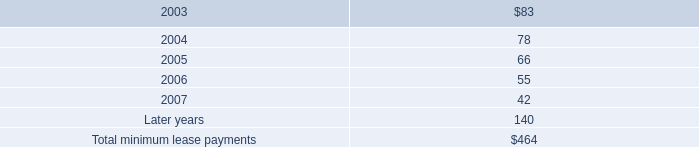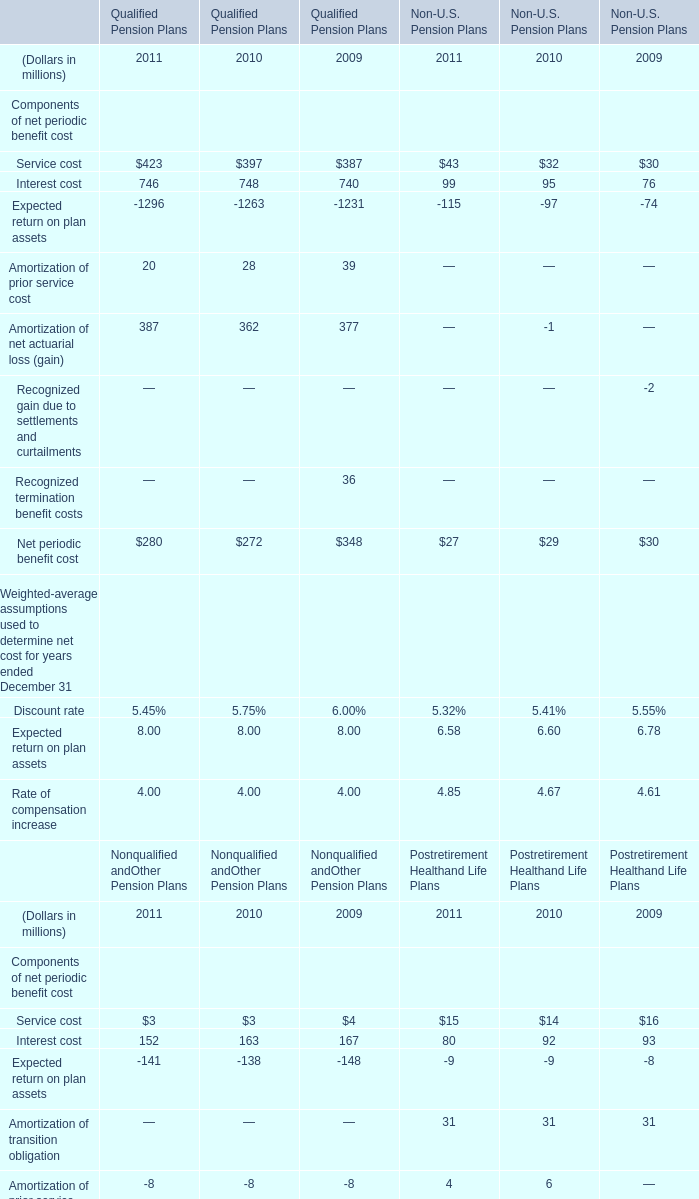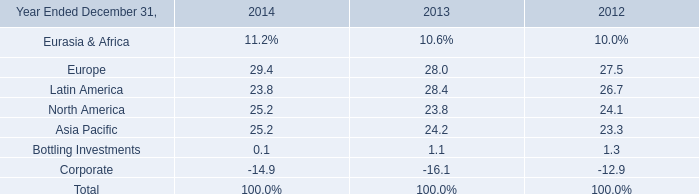What was the average value of Service cost, Interest cost, Amortization of prior service cost in Qualified Pension Plans in 2011? (in millions) 
Computations: (((423 + 746) + 20) / 3)
Answer: 396.33333. 